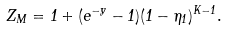<formula> <loc_0><loc_0><loc_500><loc_500>Z _ { M } = 1 + ( e ^ { - y } - 1 ) ( 1 - \eta _ { 1 } ) ^ { K - 1 } .</formula> 